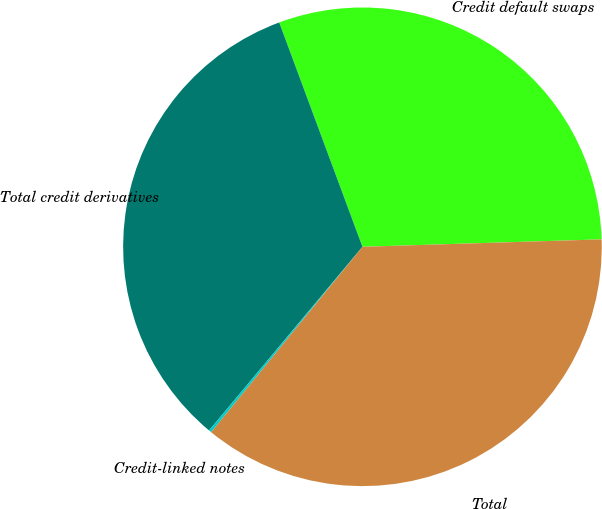Convert chart to OTSL. <chart><loc_0><loc_0><loc_500><loc_500><pie_chart><fcel>Credit default swaps<fcel>Total credit derivatives<fcel>Credit-linked notes<fcel>Total<nl><fcel>30.16%<fcel>33.27%<fcel>0.18%<fcel>36.39%<nl></chart> 